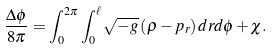Convert formula to latex. <formula><loc_0><loc_0><loc_500><loc_500>\frac { \Delta \phi } { 8 \pi } = \int _ { 0 } ^ { 2 \pi } \int _ { 0 } ^ { \ell } \sqrt { - g } \left ( \rho - p _ { r } \right ) d r d \phi + \chi .</formula> 